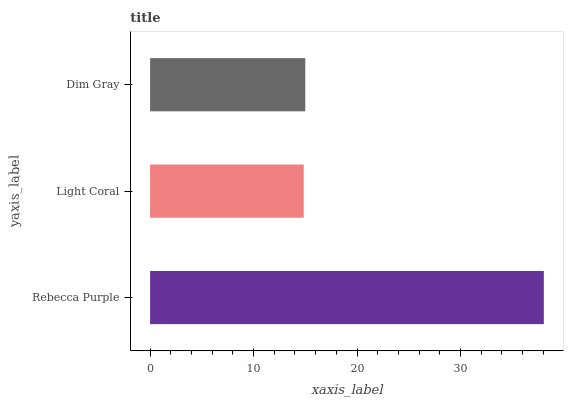Is Light Coral the minimum?
Answer yes or no. Yes. Is Rebecca Purple the maximum?
Answer yes or no. Yes. Is Dim Gray the minimum?
Answer yes or no. No. Is Dim Gray the maximum?
Answer yes or no. No. Is Dim Gray greater than Light Coral?
Answer yes or no. Yes. Is Light Coral less than Dim Gray?
Answer yes or no. Yes. Is Light Coral greater than Dim Gray?
Answer yes or no. No. Is Dim Gray less than Light Coral?
Answer yes or no. No. Is Dim Gray the high median?
Answer yes or no. Yes. Is Dim Gray the low median?
Answer yes or no. Yes. Is Rebecca Purple the high median?
Answer yes or no. No. Is Light Coral the low median?
Answer yes or no. No. 